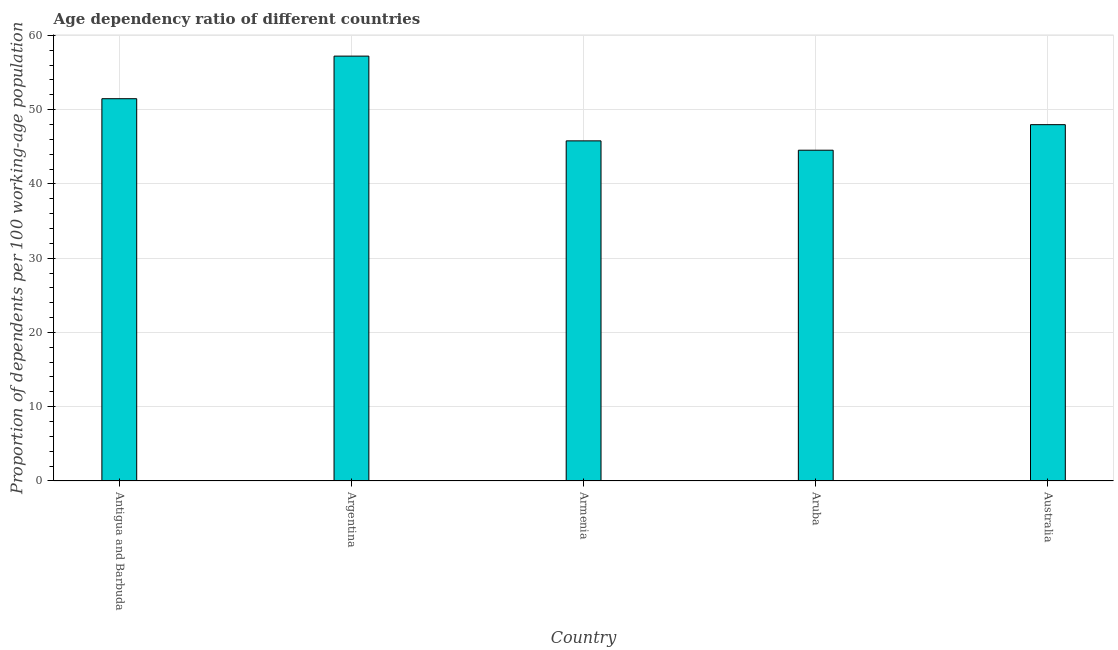What is the title of the graph?
Give a very brief answer. Age dependency ratio of different countries. What is the label or title of the X-axis?
Give a very brief answer. Country. What is the label or title of the Y-axis?
Offer a terse response. Proportion of dependents per 100 working-age population. What is the age dependency ratio in Antigua and Barbuda?
Give a very brief answer. 51.46. Across all countries, what is the maximum age dependency ratio?
Offer a very short reply. 57.2. Across all countries, what is the minimum age dependency ratio?
Give a very brief answer. 44.53. In which country was the age dependency ratio maximum?
Offer a very short reply. Argentina. In which country was the age dependency ratio minimum?
Provide a succinct answer. Aruba. What is the sum of the age dependency ratio?
Your response must be concise. 246.95. What is the difference between the age dependency ratio in Antigua and Barbuda and Armenia?
Make the answer very short. 5.67. What is the average age dependency ratio per country?
Your answer should be very brief. 49.39. What is the median age dependency ratio?
Provide a succinct answer. 47.97. What is the ratio of the age dependency ratio in Argentina to that in Australia?
Your response must be concise. 1.19. What is the difference between the highest and the second highest age dependency ratio?
Your answer should be very brief. 5.73. Is the sum of the age dependency ratio in Argentina and Australia greater than the maximum age dependency ratio across all countries?
Keep it short and to the point. Yes. What is the difference between the highest and the lowest age dependency ratio?
Provide a succinct answer. 12.67. In how many countries, is the age dependency ratio greater than the average age dependency ratio taken over all countries?
Your answer should be very brief. 2. How many bars are there?
Offer a terse response. 5. What is the difference between two consecutive major ticks on the Y-axis?
Ensure brevity in your answer.  10. What is the Proportion of dependents per 100 working-age population in Antigua and Barbuda?
Offer a terse response. 51.46. What is the Proportion of dependents per 100 working-age population in Argentina?
Your answer should be compact. 57.2. What is the Proportion of dependents per 100 working-age population of Armenia?
Give a very brief answer. 45.79. What is the Proportion of dependents per 100 working-age population in Aruba?
Offer a terse response. 44.53. What is the Proportion of dependents per 100 working-age population of Australia?
Make the answer very short. 47.97. What is the difference between the Proportion of dependents per 100 working-age population in Antigua and Barbuda and Argentina?
Make the answer very short. -5.73. What is the difference between the Proportion of dependents per 100 working-age population in Antigua and Barbuda and Armenia?
Your answer should be very brief. 5.68. What is the difference between the Proportion of dependents per 100 working-age population in Antigua and Barbuda and Aruba?
Ensure brevity in your answer.  6.93. What is the difference between the Proportion of dependents per 100 working-age population in Antigua and Barbuda and Australia?
Keep it short and to the point. 3.5. What is the difference between the Proportion of dependents per 100 working-age population in Argentina and Armenia?
Your response must be concise. 11.41. What is the difference between the Proportion of dependents per 100 working-age population in Argentina and Aruba?
Provide a succinct answer. 12.67. What is the difference between the Proportion of dependents per 100 working-age population in Argentina and Australia?
Give a very brief answer. 9.23. What is the difference between the Proportion of dependents per 100 working-age population in Armenia and Aruba?
Make the answer very short. 1.26. What is the difference between the Proportion of dependents per 100 working-age population in Armenia and Australia?
Ensure brevity in your answer.  -2.18. What is the difference between the Proportion of dependents per 100 working-age population in Aruba and Australia?
Ensure brevity in your answer.  -3.44. What is the ratio of the Proportion of dependents per 100 working-age population in Antigua and Barbuda to that in Armenia?
Ensure brevity in your answer.  1.12. What is the ratio of the Proportion of dependents per 100 working-age population in Antigua and Barbuda to that in Aruba?
Keep it short and to the point. 1.16. What is the ratio of the Proportion of dependents per 100 working-age population in Antigua and Barbuda to that in Australia?
Provide a short and direct response. 1.07. What is the ratio of the Proportion of dependents per 100 working-age population in Argentina to that in Armenia?
Give a very brief answer. 1.25. What is the ratio of the Proportion of dependents per 100 working-age population in Argentina to that in Aruba?
Give a very brief answer. 1.28. What is the ratio of the Proportion of dependents per 100 working-age population in Argentina to that in Australia?
Your answer should be very brief. 1.19. What is the ratio of the Proportion of dependents per 100 working-age population in Armenia to that in Aruba?
Offer a terse response. 1.03. What is the ratio of the Proportion of dependents per 100 working-age population in Armenia to that in Australia?
Provide a succinct answer. 0.95. What is the ratio of the Proportion of dependents per 100 working-age population in Aruba to that in Australia?
Provide a short and direct response. 0.93. 